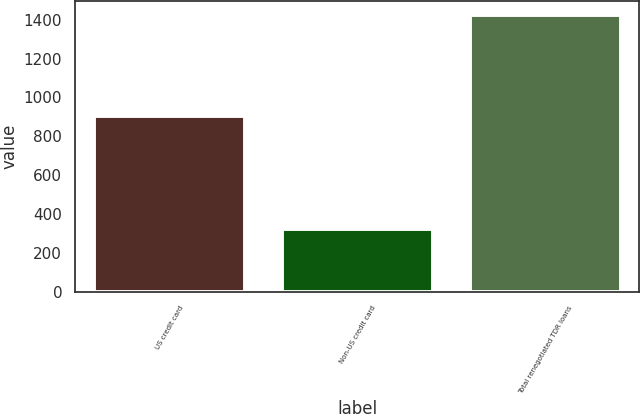<chart> <loc_0><loc_0><loc_500><loc_500><bar_chart><fcel>US credit card<fcel>Non-US credit card<fcel>Total renegotiated TDR loans<nl><fcel>902<fcel>322<fcel>1423<nl></chart> 